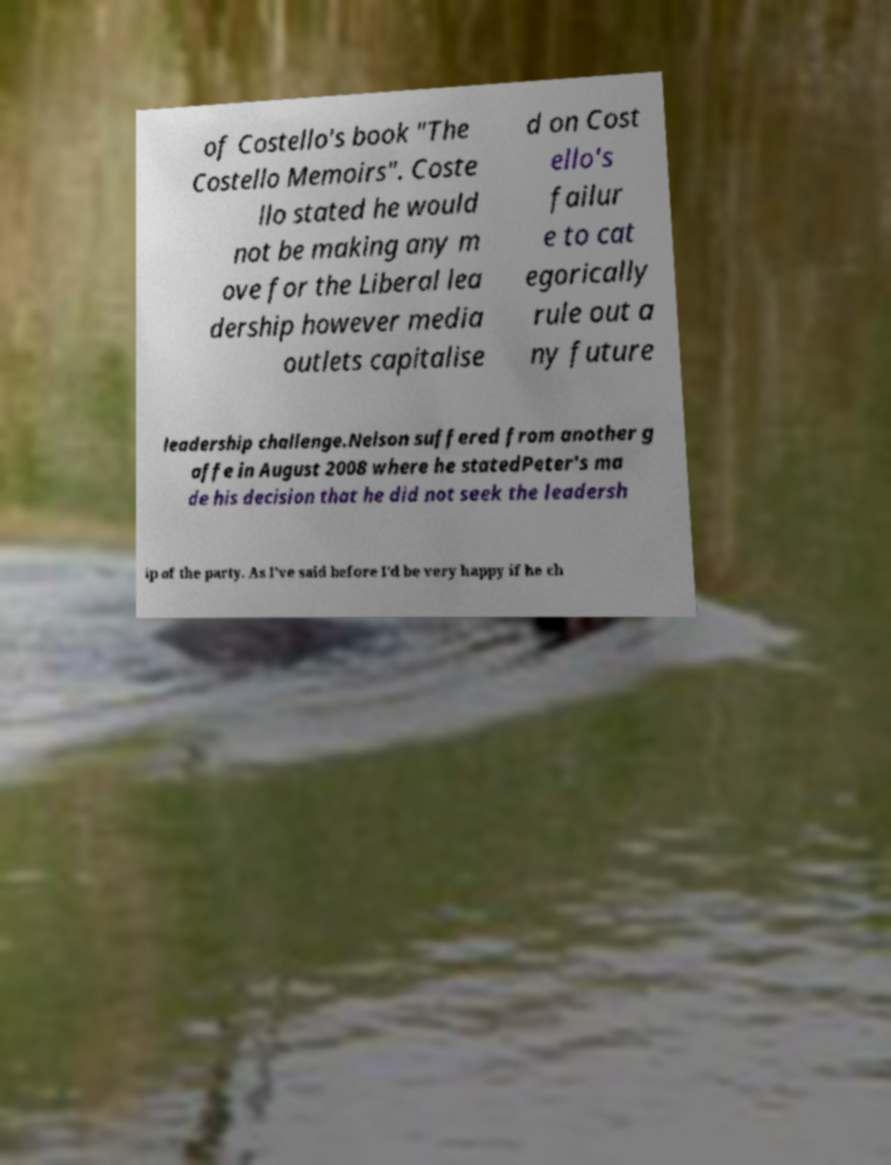I need the written content from this picture converted into text. Can you do that? of Costello's book "The Costello Memoirs". Coste llo stated he would not be making any m ove for the Liberal lea dership however media outlets capitalise d on Cost ello's failur e to cat egorically rule out a ny future leadership challenge.Nelson suffered from another g affe in August 2008 where he statedPeter's ma de his decision that he did not seek the leadersh ip of the party. As I've said before I'd be very happy if he ch 